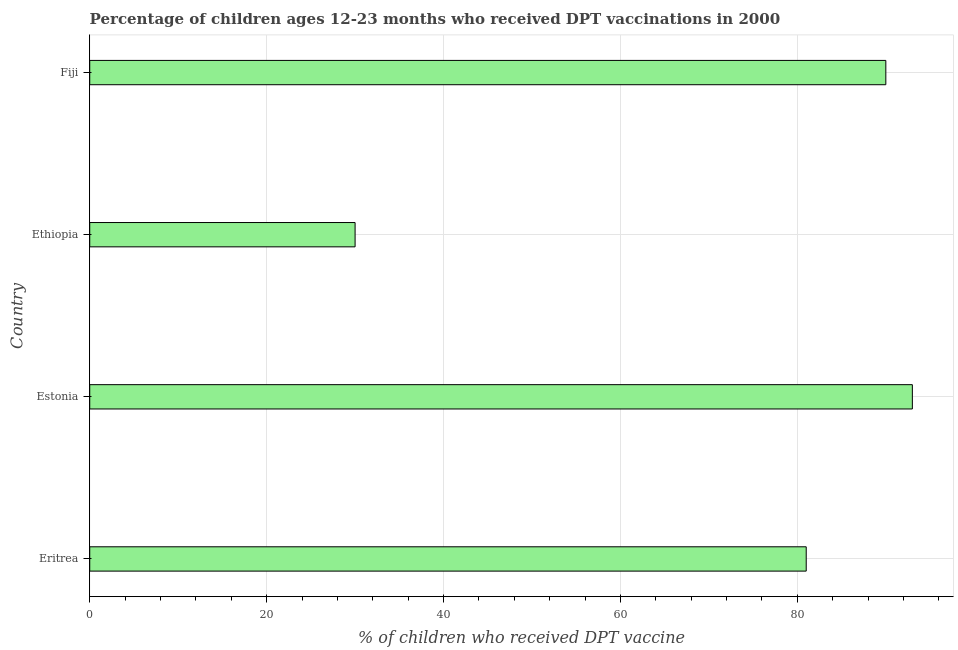Does the graph contain any zero values?
Ensure brevity in your answer.  No. Does the graph contain grids?
Ensure brevity in your answer.  Yes. What is the title of the graph?
Your answer should be compact. Percentage of children ages 12-23 months who received DPT vaccinations in 2000. What is the label or title of the X-axis?
Your answer should be compact. % of children who received DPT vaccine. What is the label or title of the Y-axis?
Ensure brevity in your answer.  Country. Across all countries, what is the maximum percentage of children who received dpt vaccine?
Ensure brevity in your answer.  93. In which country was the percentage of children who received dpt vaccine maximum?
Your response must be concise. Estonia. In which country was the percentage of children who received dpt vaccine minimum?
Your answer should be very brief. Ethiopia. What is the sum of the percentage of children who received dpt vaccine?
Provide a succinct answer. 294. What is the difference between the percentage of children who received dpt vaccine in Eritrea and Estonia?
Your answer should be compact. -12. What is the average percentage of children who received dpt vaccine per country?
Offer a very short reply. 73.5. What is the median percentage of children who received dpt vaccine?
Keep it short and to the point. 85.5. What is the ratio of the percentage of children who received dpt vaccine in Eritrea to that in Estonia?
Provide a succinct answer. 0.87. Is the percentage of children who received dpt vaccine in Eritrea less than that in Ethiopia?
Your answer should be compact. No. Are the values on the major ticks of X-axis written in scientific E-notation?
Offer a terse response. No. What is the % of children who received DPT vaccine in Eritrea?
Make the answer very short. 81. What is the % of children who received DPT vaccine in Estonia?
Your answer should be compact. 93. What is the % of children who received DPT vaccine in Ethiopia?
Your response must be concise. 30. What is the % of children who received DPT vaccine in Fiji?
Provide a succinct answer. 90. What is the difference between the % of children who received DPT vaccine in Eritrea and Fiji?
Ensure brevity in your answer.  -9. What is the difference between the % of children who received DPT vaccine in Estonia and Ethiopia?
Your answer should be very brief. 63. What is the difference between the % of children who received DPT vaccine in Estonia and Fiji?
Offer a terse response. 3. What is the difference between the % of children who received DPT vaccine in Ethiopia and Fiji?
Offer a very short reply. -60. What is the ratio of the % of children who received DPT vaccine in Eritrea to that in Estonia?
Keep it short and to the point. 0.87. What is the ratio of the % of children who received DPT vaccine in Eritrea to that in Ethiopia?
Offer a terse response. 2.7. What is the ratio of the % of children who received DPT vaccine in Estonia to that in Ethiopia?
Offer a terse response. 3.1. What is the ratio of the % of children who received DPT vaccine in Estonia to that in Fiji?
Your answer should be compact. 1.03. What is the ratio of the % of children who received DPT vaccine in Ethiopia to that in Fiji?
Your answer should be very brief. 0.33. 